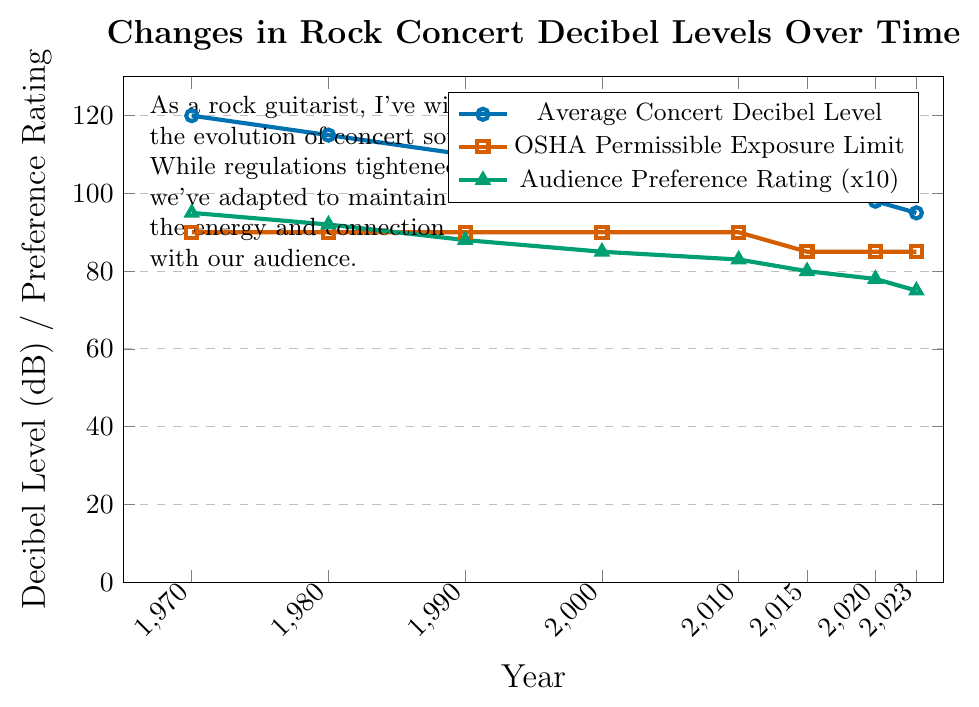What's the average concert decibel level in 2000 and 2023? Look for the values corresponding to the years 2000 and 2023 in the "Average Concert Decibel Level" data series: in 2000, it is 105 dB, and in 2023, it is 95 dB. The average is calculated as (105 + 95) / 2.
Answer: 100 dB How does the audience preference rating change from 1970 to 2023? Identify the audience preference rating in 1970 and 2023 from the data: it is 9.5 in 1970 and 7.5 in 2023. The change is calculated by subtracting the 2023 value from the 1970 value (9.5 - 7.5).
Answer: Decreases by 2 Which year shows the largest gap between the average concert decibel level and the OSHA permissible exposure limit? For each year, calculate the difference between the average concert decibel level and the OSHA permissible exposure limit. Identify the year with the highest difference: in 1970, the gap is 120 - 90 = 30 dB, and for other years, the gaps are smaller.
Answer: 1970 Between 2015 and 2023, how did the OSHA permissible exposure limit change? Look at the values for the OSHA permissible exposure limit in 2015 and 2023: it is 85 dB for both years. Therefore, the permissible exposure limit did not change.
Answer: No change In which decade did the average concert decibel level see the steepest decline? Calculate the decrease in dB for each decade: 1970s (120 to 115), 1980s (115 to 110), 1990s (110 to 105), 2000s (105 to 102), and 2010s (102 to 100). The steepest decline is by 5 dB in the 1970s and 1980s, but the most significant change is noticed in the 2010s and 2020s with the decline of 3, 2, and 3 (5 dB), respectively.
Answer: 2010s and 2020s 